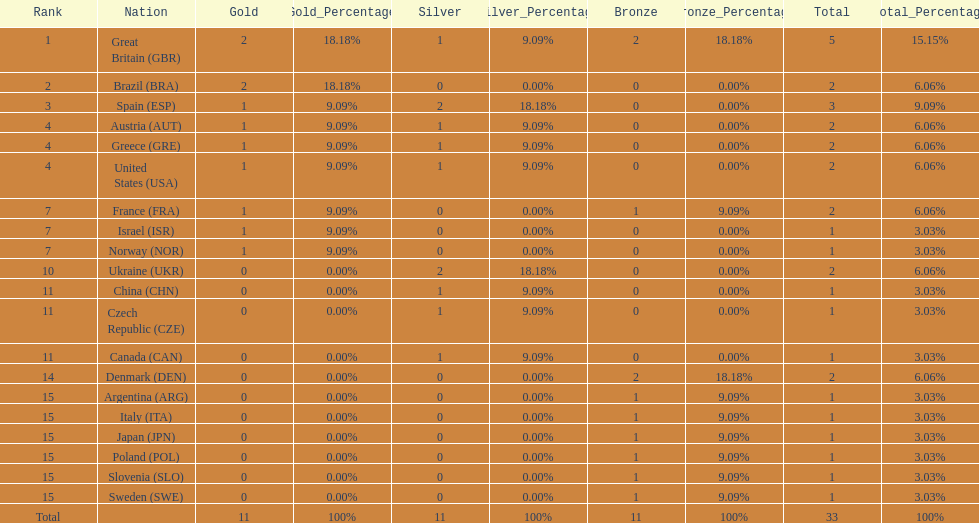Which nation was the only one to receive 3 medals? Spain (ESP). 